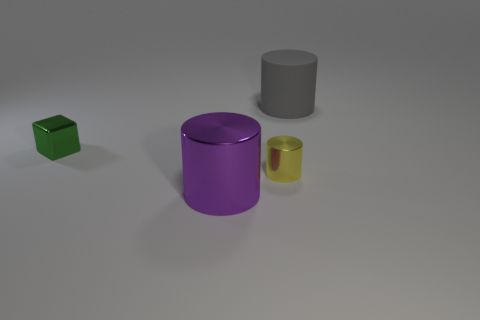What number of tiny objects are the same color as the tiny cylinder?
Offer a terse response. 0. Is the size of the object in front of the yellow object the same as the big matte cylinder?
Keep it short and to the point. Yes. There is a metal thing that is both to the left of the tiny yellow metal object and behind the large metallic cylinder; what is its color?
Give a very brief answer. Green. How many things are tiny cylinders or metallic objects in front of the green block?
Provide a short and direct response. 2. There is a big object behind the large cylinder that is on the left side of the big cylinder behind the tiny green metal block; what is it made of?
Ensure brevity in your answer.  Rubber. Is there anything else that has the same material as the yellow cylinder?
Your answer should be compact. Yes. Do the cylinder that is behind the green object and the block have the same color?
Offer a very short reply. No. What number of green things are big rubber cylinders or tiny metal blocks?
Your answer should be very brief. 1. What number of other things are the same shape as the large gray matte object?
Your answer should be compact. 2. Do the yellow cylinder and the cube have the same material?
Ensure brevity in your answer.  Yes. 